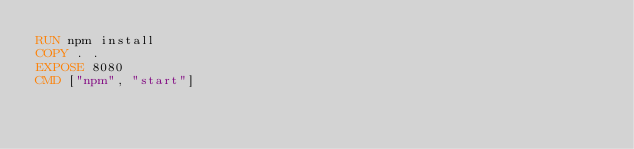Convert code to text. <code><loc_0><loc_0><loc_500><loc_500><_Dockerfile_>RUN npm install
COPY . .
EXPOSE 8080
CMD ["npm", "start"]</code> 